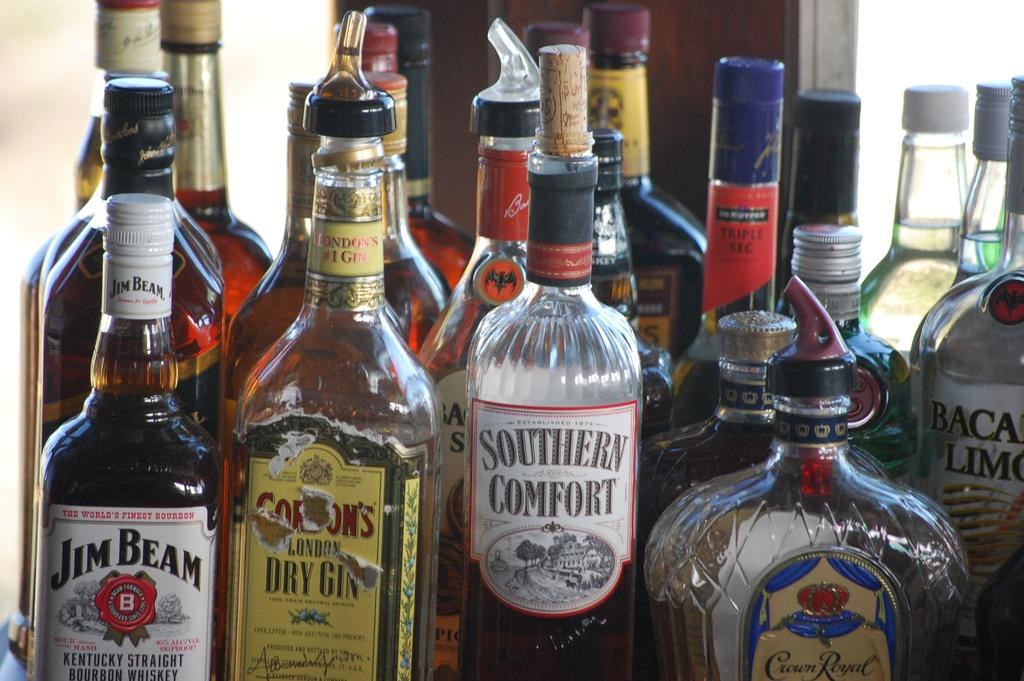<image>
Render a clear and concise summary of the photo. Jim Bean Crown Royal and various other whiskey beverages sitting in a corner. 